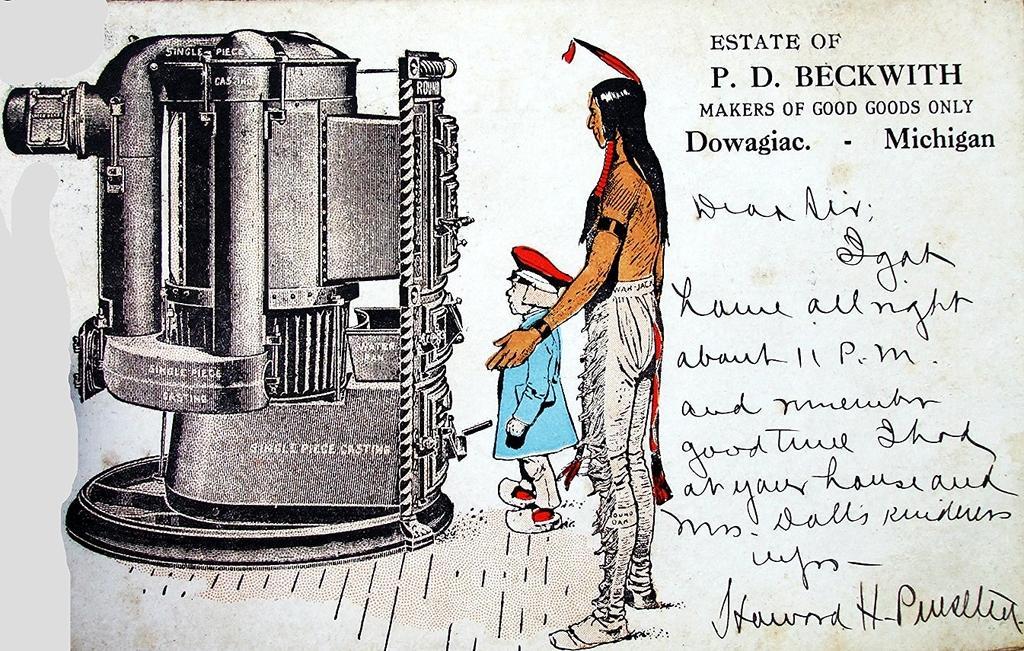Could you give a brief overview of what you see in this image? In the image there is a letter. To the left side of the image there is a machine. Beside the machine there is a person with blue jacket and a cap on his head is standing. Behind him there is another person standing. And to the right side of the image there is an address. And below the address there is something written on it. 